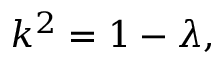<formula> <loc_0><loc_0><loc_500><loc_500>k ^ { 2 } = 1 - \lambda ,</formula> 